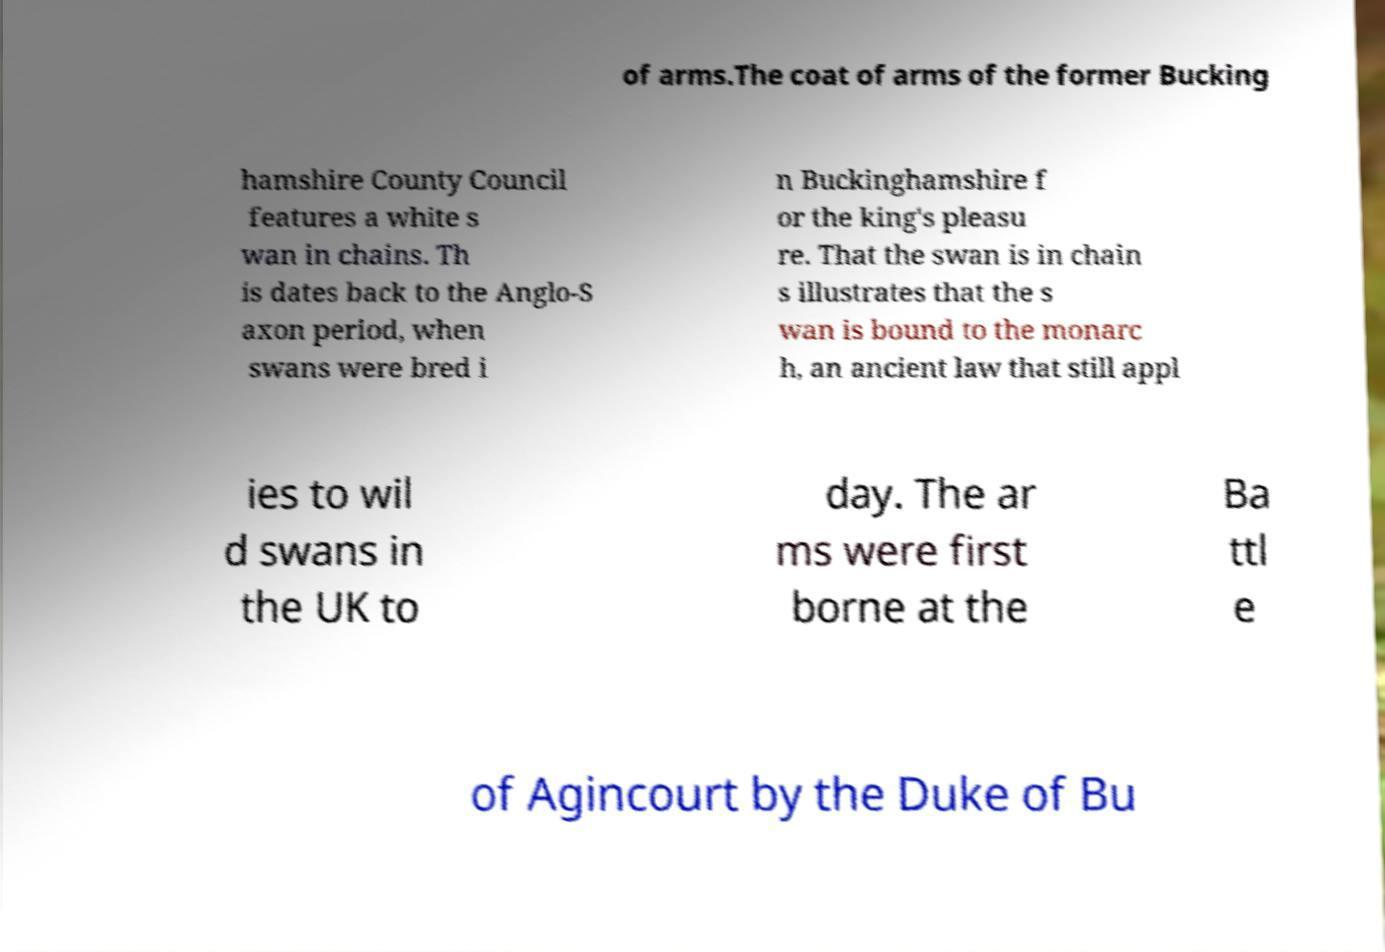Could you assist in decoding the text presented in this image and type it out clearly? of arms.The coat of arms of the former Bucking hamshire County Council features a white s wan in chains. Th is dates back to the Anglo-S axon period, when swans were bred i n Buckinghamshire f or the king's pleasu re. That the swan is in chain s illustrates that the s wan is bound to the monarc h, an ancient law that still appl ies to wil d swans in the UK to day. The ar ms were first borne at the Ba ttl e of Agincourt by the Duke of Bu 